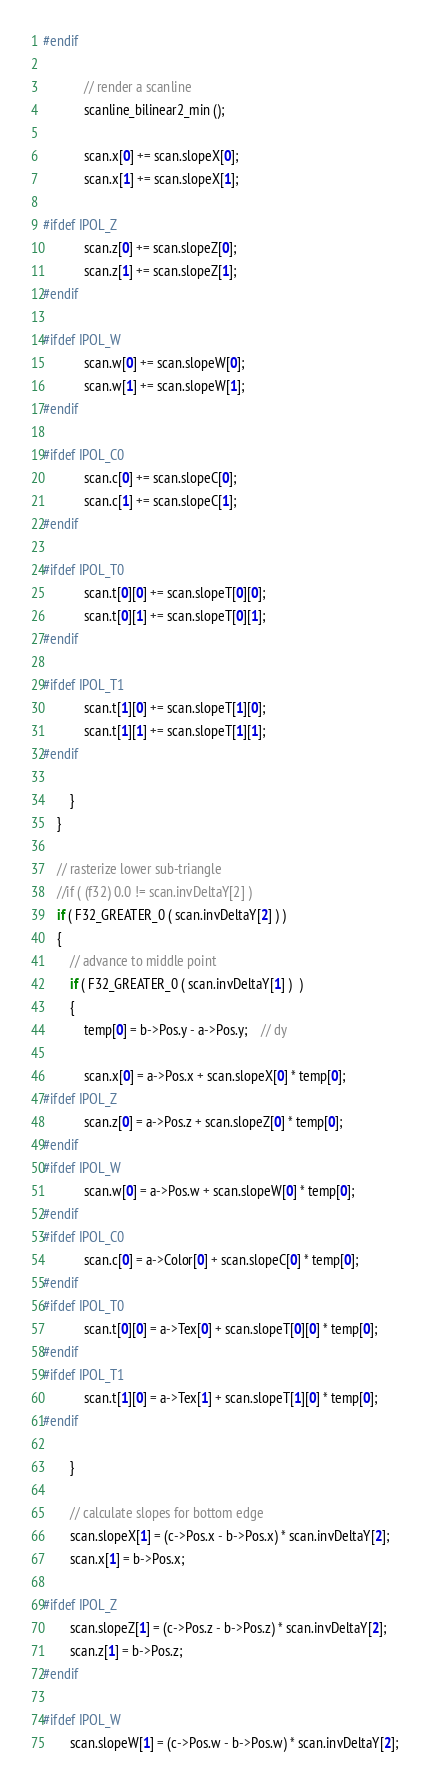<code> <loc_0><loc_0><loc_500><loc_500><_C++_>#endif

			// render a scanline
			scanline_bilinear2_min ();

			scan.x[0] += scan.slopeX[0];
			scan.x[1] += scan.slopeX[1];

#ifdef IPOL_Z
			scan.z[0] += scan.slopeZ[0];
			scan.z[1] += scan.slopeZ[1];
#endif

#ifdef IPOL_W
			scan.w[0] += scan.slopeW[0];
			scan.w[1] += scan.slopeW[1];
#endif

#ifdef IPOL_C0
			scan.c[0] += scan.slopeC[0];
			scan.c[1] += scan.slopeC[1];
#endif

#ifdef IPOL_T0
			scan.t[0][0] += scan.slopeT[0][0];
			scan.t[0][1] += scan.slopeT[0][1];
#endif

#ifdef IPOL_T1
			scan.t[1][0] += scan.slopeT[1][0];
			scan.t[1][1] += scan.slopeT[1][1];
#endif

		}
	}

	// rasterize lower sub-triangle
	//if ( (f32) 0.0 != scan.invDeltaY[2] )
	if ( F32_GREATER_0 ( scan.invDeltaY[2] ) )
	{
		// advance to middle point
		if ( F32_GREATER_0 ( scan.invDeltaY[1] )  )
		{
			temp[0] = b->Pos.y - a->Pos.y;	// dy

			scan.x[0] = a->Pos.x + scan.slopeX[0] * temp[0];
#ifdef IPOL_Z
			scan.z[0] = a->Pos.z + scan.slopeZ[0] * temp[0];
#endif
#ifdef IPOL_W
			scan.w[0] = a->Pos.w + scan.slopeW[0] * temp[0];
#endif
#ifdef IPOL_C0
			scan.c[0] = a->Color[0] + scan.slopeC[0] * temp[0];
#endif
#ifdef IPOL_T0
			scan.t[0][0] = a->Tex[0] + scan.slopeT[0][0] * temp[0];
#endif
#ifdef IPOL_T1
			scan.t[1][0] = a->Tex[1] + scan.slopeT[1][0] * temp[0];
#endif

		}

		// calculate slopes for bottom edge
		scan.slopeX[1] = (c->Pos.x - b->Pos.x) * scan.invDeltaY[2];
		scan.x[1] = b->Pos.x;

#ifdef IPOL_Z
		scan.slopeZ[1] = (c->Pos.z - b->Pos.z) * scan.invDeltaY[2];
		scan.z[1] = b->Pos.z;
#endif

#ifdef IPOL_W
		scan.slopeW[1] = (c->Pos.w - b->Pos.w) * scan.invDeltaY[2];</code> 